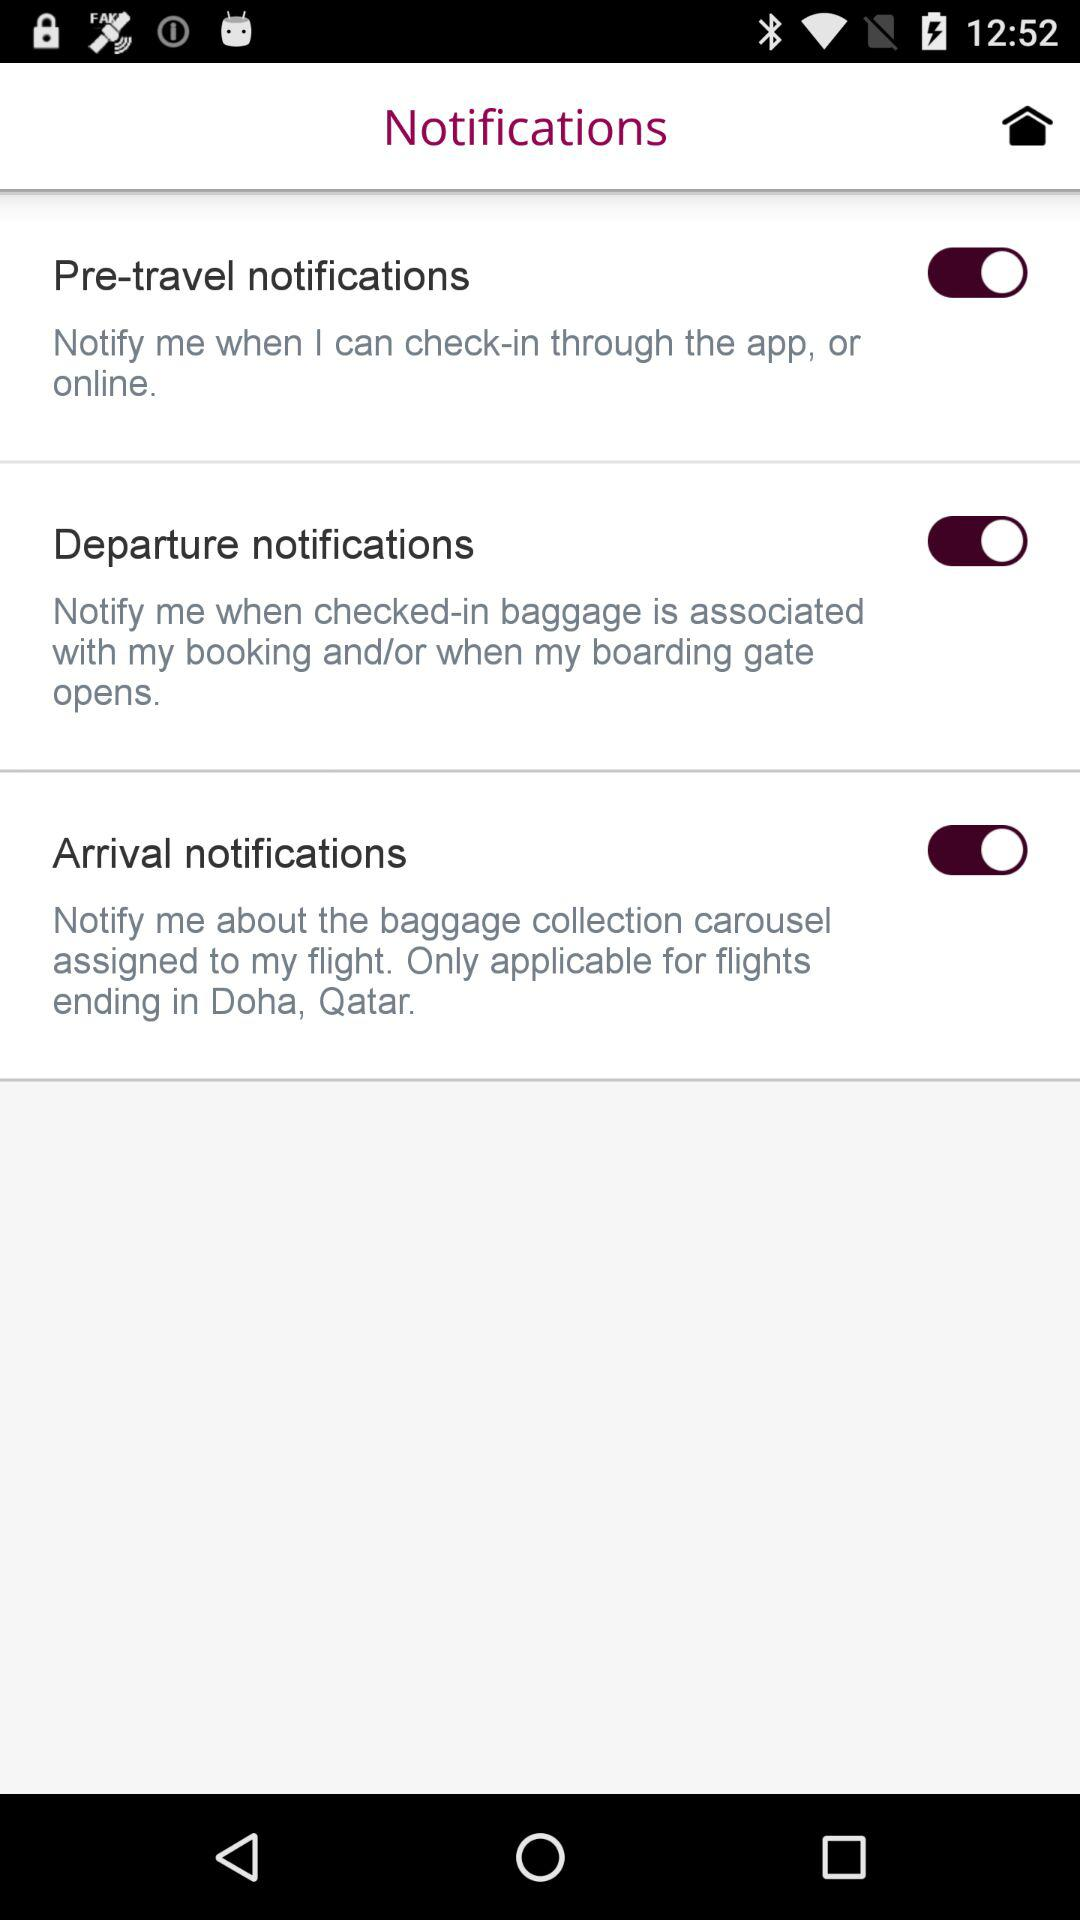What is the status of the notification setting?
When the provided information is insufficient, respond with <no answer>. <no answer> 